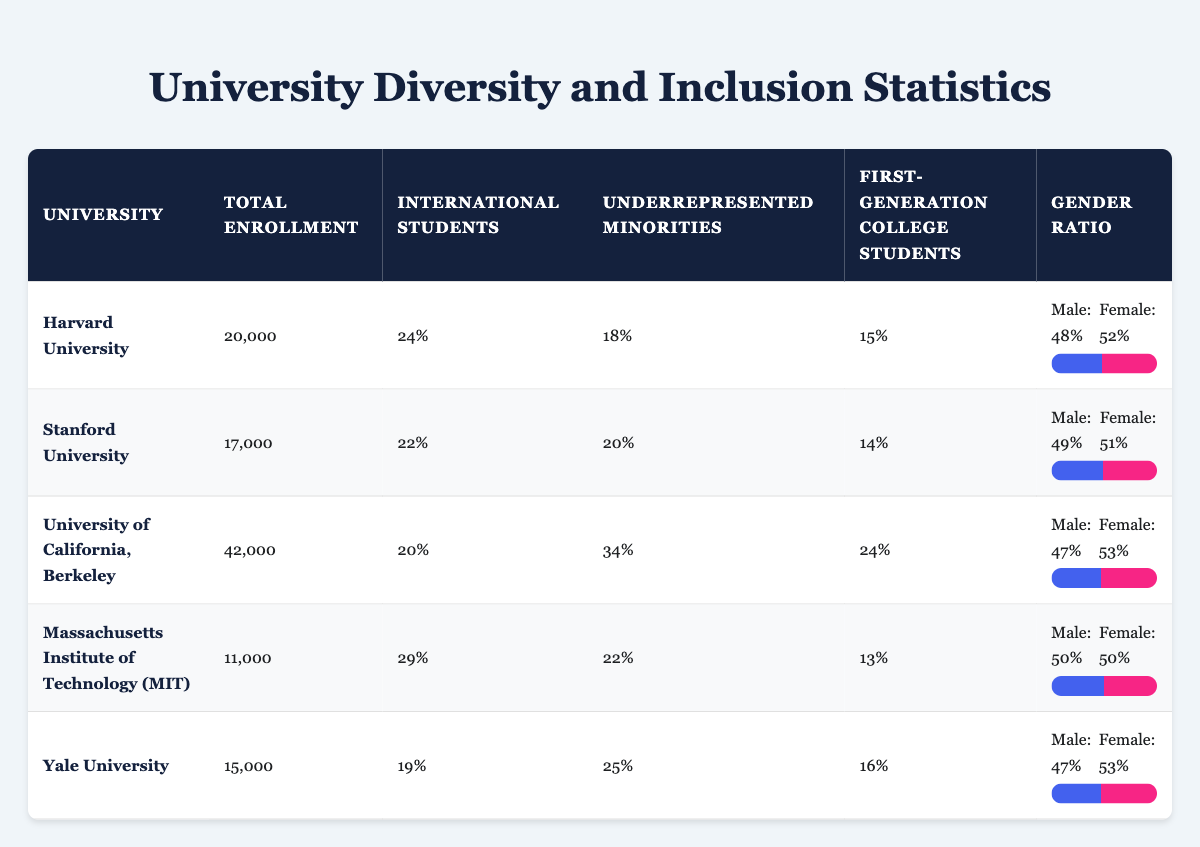What is the total student enrollment at Harvard University? The table shows the total student enrollment for Harvard University as 20,000.
Answer: 20,000 What percentage of students at Stanford University are first-generation college students? According to the table, 14% of the total students at Stanford University are first-generation college students.
Answer: 14% Which university has the highest percentage of underrepresented minorities? By comparing the percentages, the University of California, Berkeley has the highest percentage at 34%.
Answer: 34% What is the gender ratio of male students to female students at the Massachusetts Institute of Technology? The table lists the gender ratio at MIT as Male: 50% and Female: 50%.
Answer: Male: 50%, Female: 50% Is the percentage of underrepresented minorities at Yale University greater than that at Harvard University? Yale University has 25% underrepresented minorities while Harvard has 18%, therefore yes, Yale has a greater percentage.
Answer: Yes What is the average percentage of international students across all the universities listed? The percentages of international students are 24, 22, 20, 29, and 19. Summing these gives 24 + 22 + 20 + 29 + 19 = 114. Dividing this sum by 5 gives an average of 114 / 5 = 22.8%.
Answer: 22.8% How many universities reported a higher percentage of first-generation college students than MIT? The percentages for first-generation college students are 15% (Harvard), 14% (Stanford), 24% (UC Berkeley), and 16% (Yale). MIT has 13%, so four universities reported a higher percentage.
Answer: 4 Which university has the lowest percentage of international students? The table shows that Yale University has the lowest percentage of international students at 19%.
Answer: 19% Does the University of California, Berkeley have a higher total enrollment than Stanford University? UC Berkeley has 42,000 students enrolled, while Stanford has 17,000, so yes, Berkeley has a higher total enrollment.
Answer: Yes 